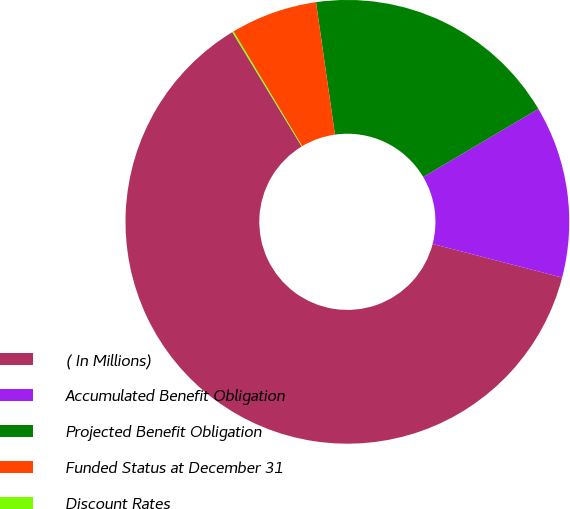<chart> <loc_0><loc_0><loc_500><loc_500><pie_chart><fcel>( In Millions)<fcel>Accumulated Benefit Obligation<fcel>Projected Benefit Obligation<fcel>Funded Status at December 31<fcel>Discount Rates<nl><fcel>62.28%<fcel>12.54%<fcel>18.76%<fcel>6.32%<fcel>0.1%<nl></chart> 